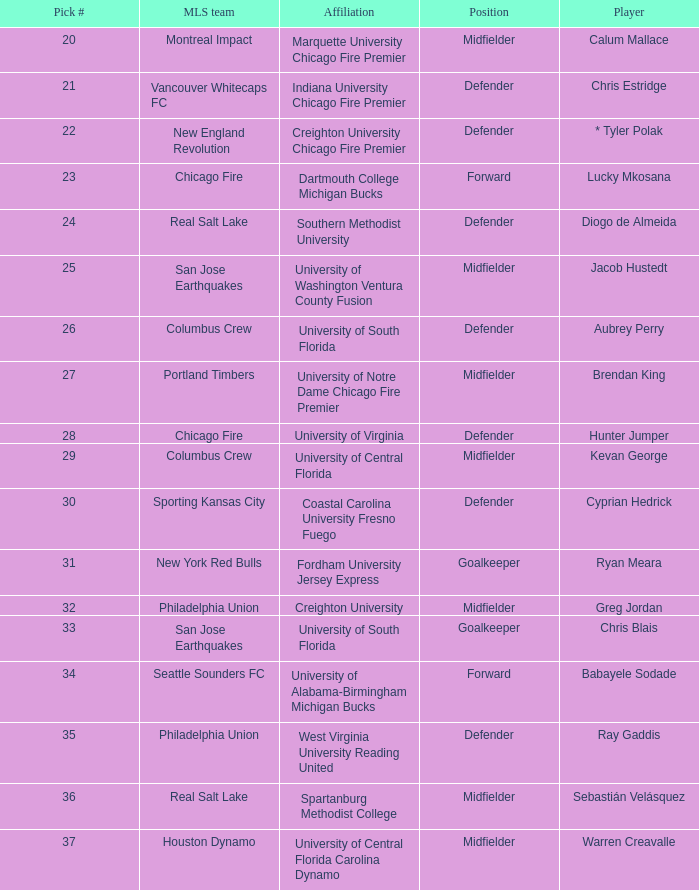What pick number is Kevan George? 29.0. 